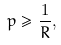<formula> <loc_0><loc_0><loc_500><loc_500>p \geq \frac { 1 } { R } ,</formula> 